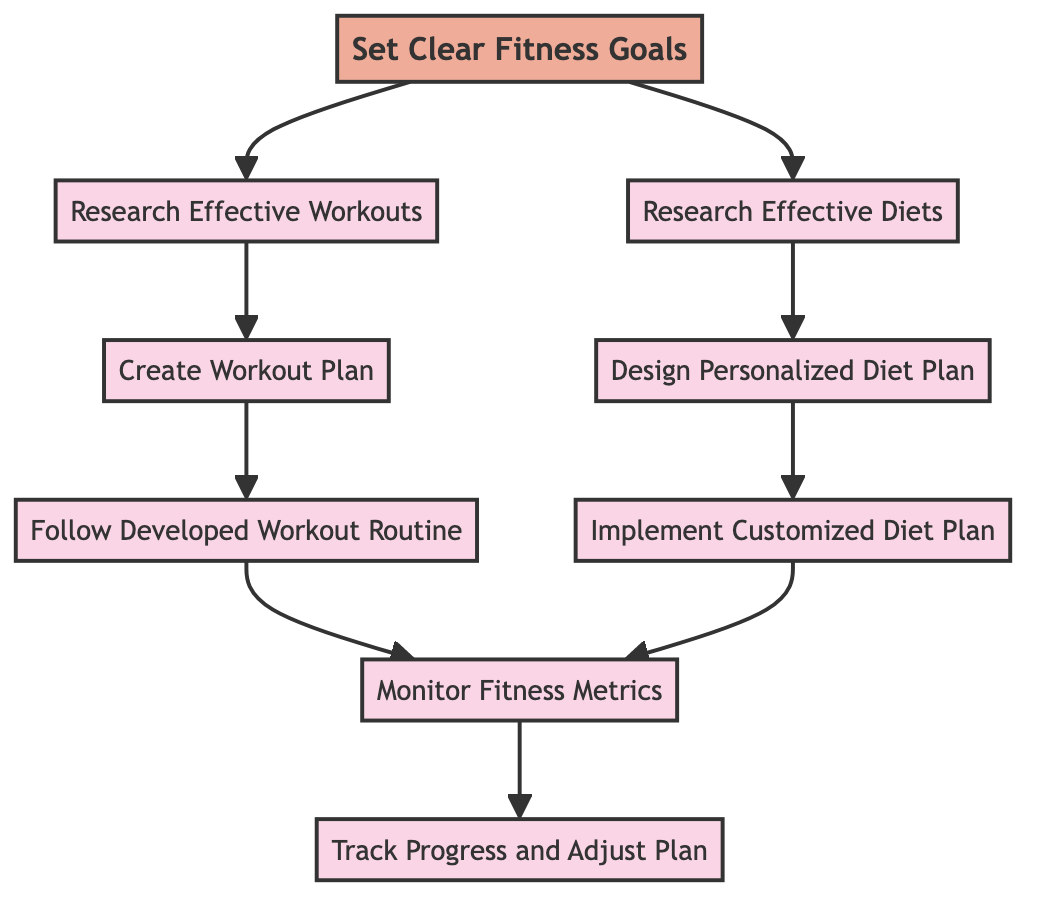What is the starting point of the flowchart? The flowchart begins with the node labeled "Set Clear Fitness Goals," which is identified as the starting point.
Answer: Set Clear Fitness Goals How many nodes are in the flowchart? Counting all the unique elements in the flowchart, there are a total of eight process nodes and one start node, resulting in nine nodes in total.
Answer: Nine Which two activities follow the goal-setting process? After the "Set Clear Fitness Goals" node, the process flows to "Research Effective Workouts" and "Research Effective Diets," both of which are linked to the starting point.
Answer: Research Effective Workouts, Research Effective Diets What comes after "Implement Customized Diet Plan"? According to the flow of the diagram, the next step after "Implement Customized Diet Plan" is "Monitor Fitness Metrics."
Answer: Monitor Fitness Metrics Which nodes culminate in "Track Progress and Adjust Plan"? The flow leading to "Track Progress and Adjust Plan" is initiated from "Monitor Fitness Metrics," and it represents the final step in the routine.
Answer: Monitor Fitness Metrics How many steps are there between setting goals and tracking progress? After setting goals, the flowchart outlines a total of five steps that lead to "Track Progress and Adjust Plan": research workouts, create workout plan, follow developed workout routine, monitor fitness metrics, and finally track adjust.
Answer: Five What type of plans are designed in the flowchart? The diagram shows the development of both a "Personalized Diet Plan" and a "Workout Plan," indicating that both types of plans are created as part of establishing a sustainable fitness routine.
Answer: Personalized Diet Plan, Workout Plan Which two nodes represent actions involving metrics? The nodes "Monitor Fitness Metrics" and "Track Progress and Adjust Plan" are both focused on activities involving metrics in the flowchart.
Answer: Monitor Fitness Metrics, Track Progress and Adjust Plan 